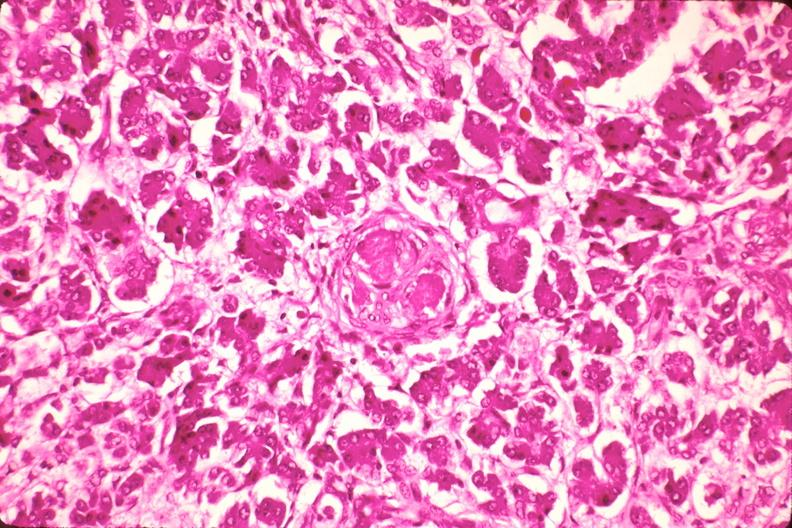does this section show pancreas, microthrombi, thrombotic thrombocytopenic purpura?
Answer the question using a single word or phrase. No 